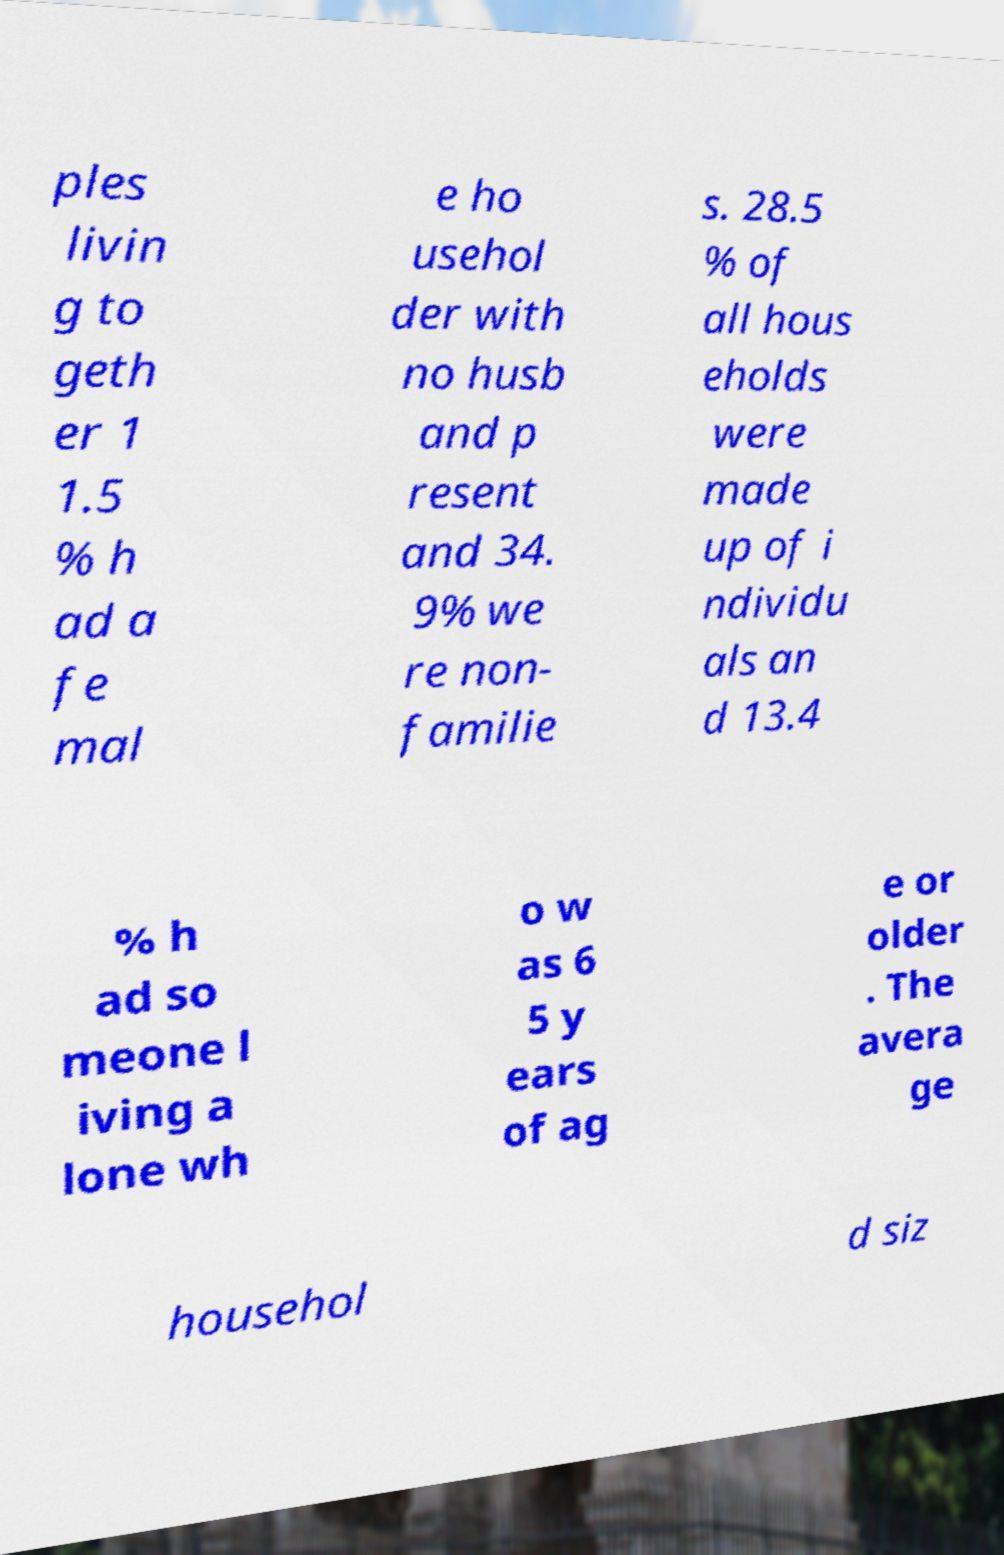There's text embedded in this image that I need extracted. Can you transcribe it verbatim? ples livin g to geth er 1 1.5 % h ad a fe mal e ho usehol der with no husb and p resent and 34. 9% we re non- familie s. 28.5 % of all hous eholds were made up of i ndividu als an d 13.4 % h ad so meone l iving a lone wh o w as 6 5 y ears of ag e or older . The avera ge househol d siz 